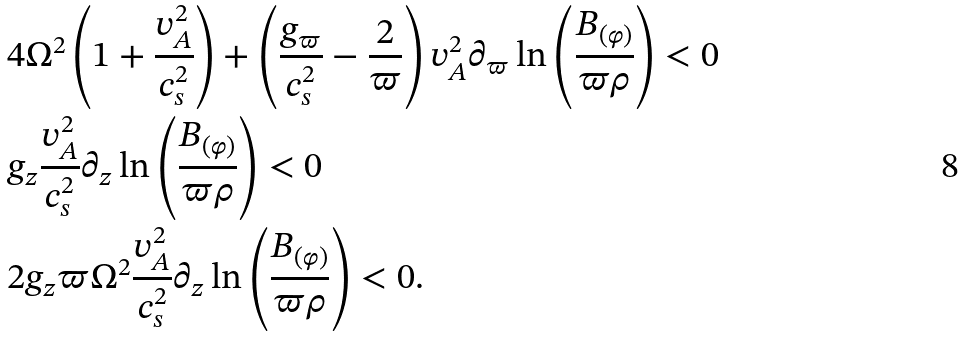<formula> <loc_0><loc_0><loc_500><loc_500>& 4 \Omega ^ { 2 } \left ( 1 + \frac { v _ { A } ^ { 2 } } { c _ { s } ^ { 2 } } \right ) + \left ( \frac { g _ { \varpi } } { c _ { s } ^ { 2 } } - \frac { 2 } { \varpi } \right ) v _ { A } ^ { 2 } \partial _ { \varpi } \ln \left ( \frac { B _ { ( \varphi ) } } { \varpi \rho } \right ) < 0 \\ & g _ { z } \frac { v _ { A } ^ { 2 } } { c _ { s } ^ { 2 } } \partial _ { z } \ln \left ( \frac { B _ { ( \varphi ) } } { \varpi \rho } \right ) < 0 \\ & 2 g _ { z } \varpi \Omega ^ { 2 } \frac { v _ { A } ^ { 2 } } { c _ { s } ^ { 2 } } \partial _ { z } \ln \left ( \frac { B _ { ( \varphi ) } } { \varpi \rho } \right ) < 0 .</formula> 